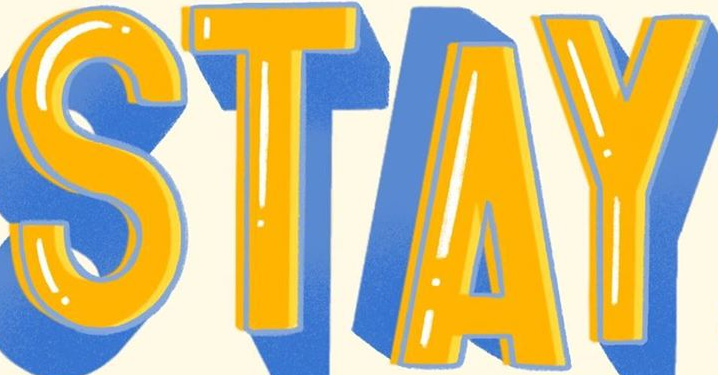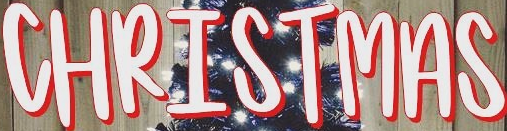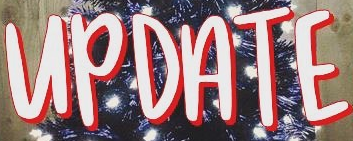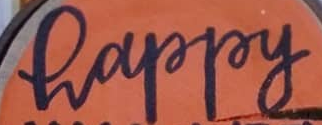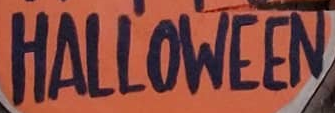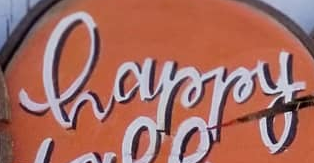Read the text content from these images in order, separated by a semicolon. STAY; CHRISTMAS; UPDATE; happy; HALLOWEEN; happy 